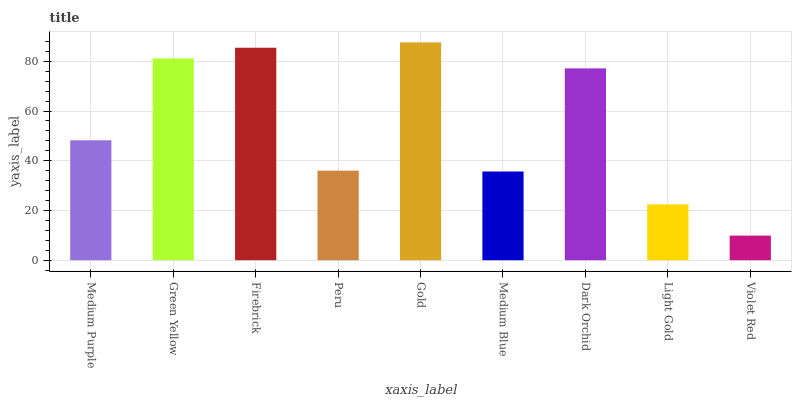Is Violet Red the minimum?
Answer yes or no. Yes. Is Gold the maximum?
Answer yes or no. Yes. Is Green Yellow the minimum?
Answer yes or no. No. Is Green Yellow the maximum?
Answer yes or no. No. Is Green Yellow greater than Medium Purple?
Answer yes or no. Yes. Is Medium Purple less than Green Yellow?
Answer yes or no. Yes. Is Medium Purple greater than Green Yellow?
Answer yes or no. No. Is Green Yellow less than Medium Purple?
Answer yes or no. No. Is Medium Purple the high median?
Answer yes or no. Yes. Is Medium Purple the low median?
Answer yes or no. Yes. Is Peru the high median?
Answer yes or no. No. Is Violet Red the low median?
Answer yes or no. No. 